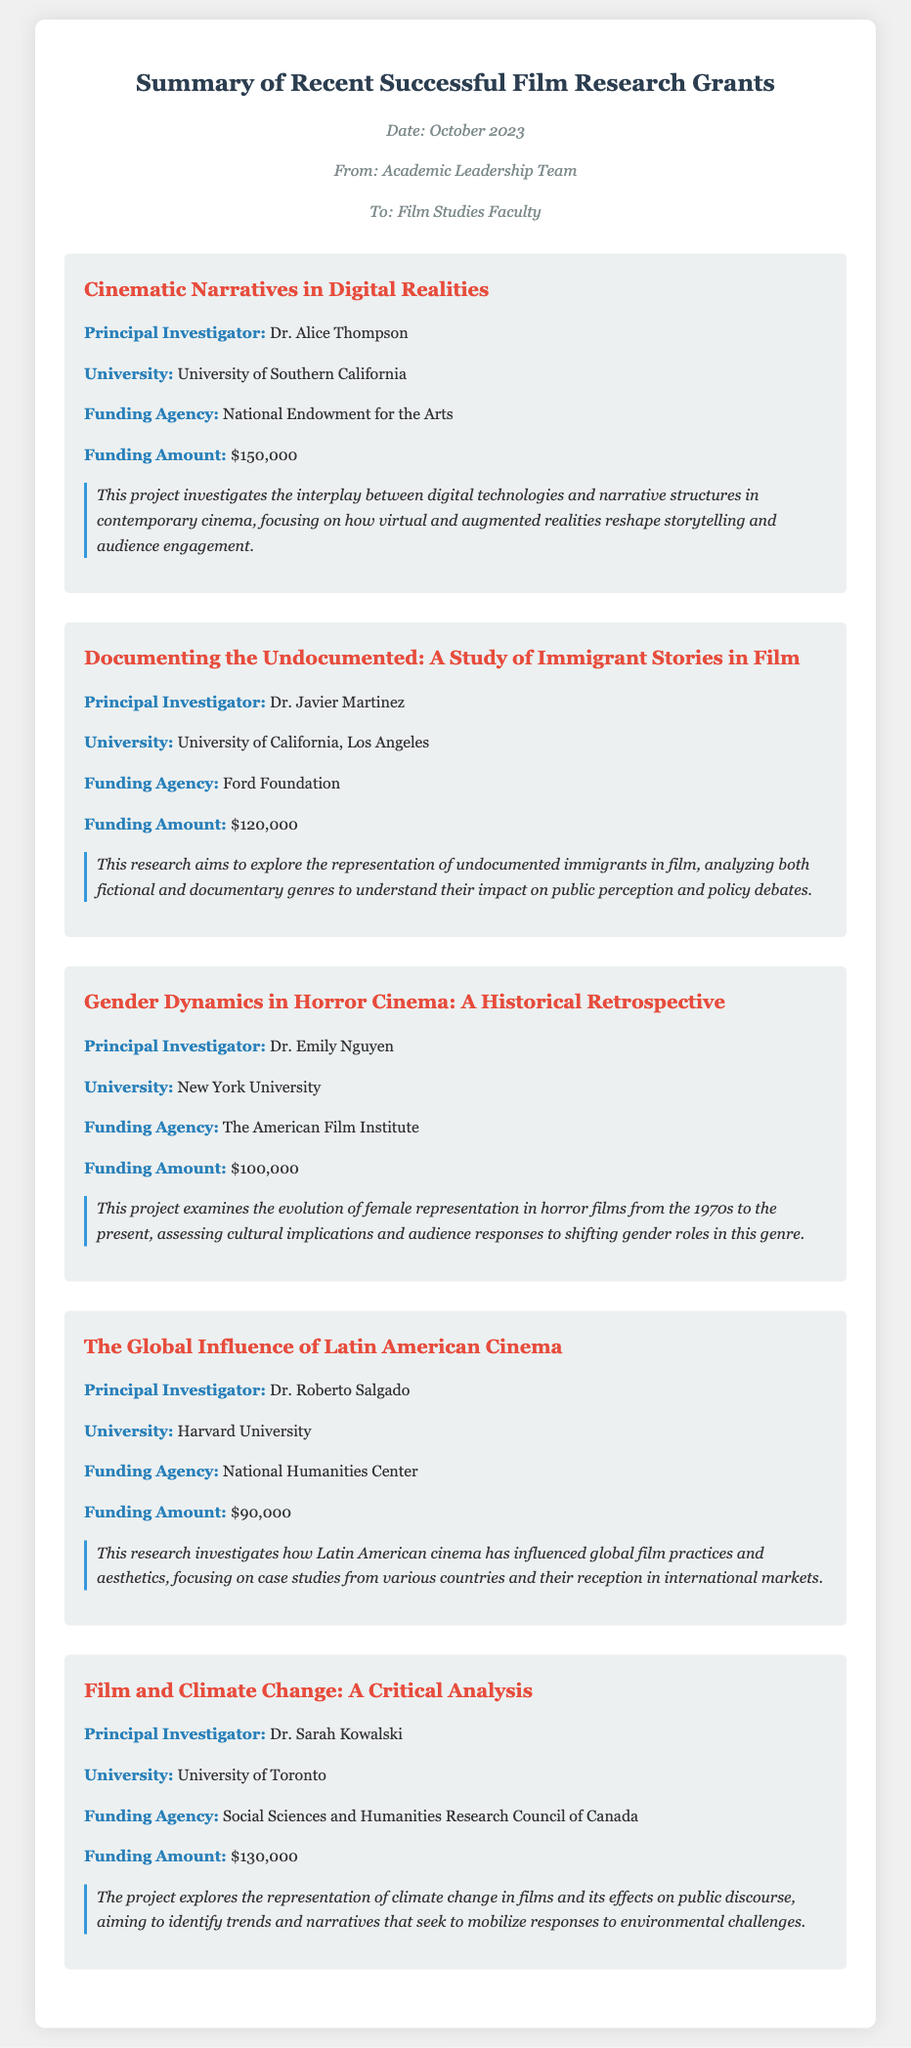What is the title of the project led by Dr. Alice Thompson? The title is mentioned in the section related to Dr. Alice Thompson's project.
Answer: Cinematic Narratives in Digital Realities Who is the principal investigator for the film project on climate change? The principal investigator is specified in the project details for "Film and Climate Change: A Critical Analysis."
Answer: Dr. Sarah Kowalski How much funding did the Ford Foundation provide for Dr. Javier Martinez's project? The funding amount is stated in the project details for Dr. Javier Martinez's research on immigrant stories in film.
Answer: $120,000 What university is Dr. Emily Nguyen affiliated with? The university for Dr. Emily Nguyen is provided in her project details section.
Answer: New York University What research topic explores gender dynamics in horror cinema? The project title discusses the specific focus of the research conducted by Dr. Emily Nguyen.
Answer: Gender Dynamics in Horror Cinema: A Historical Retrospective Which funding agency supported Dr. Roberto Salgado's research? The funding agency is stated in the project overview for "The Global Influence of Latin American Cinema."
Answer: National Humanities Center What amount did the National Endowment for the Arts allocate to the project on digital narratives? The funding amount for Dr. Alice Thompson's project is available in the project summary.
Answer: $150,000 What is the main focus of the project titled "Documenting the Undocumented"? The main focus is described in the project overview related to Dr. Javier Martinez's research.
Answer: Representation of undocumented immigrants in film How many projects were highlighted in the summary memo? The number of projects can be counted from the distinct project sections in the memo.
Answer: Five 